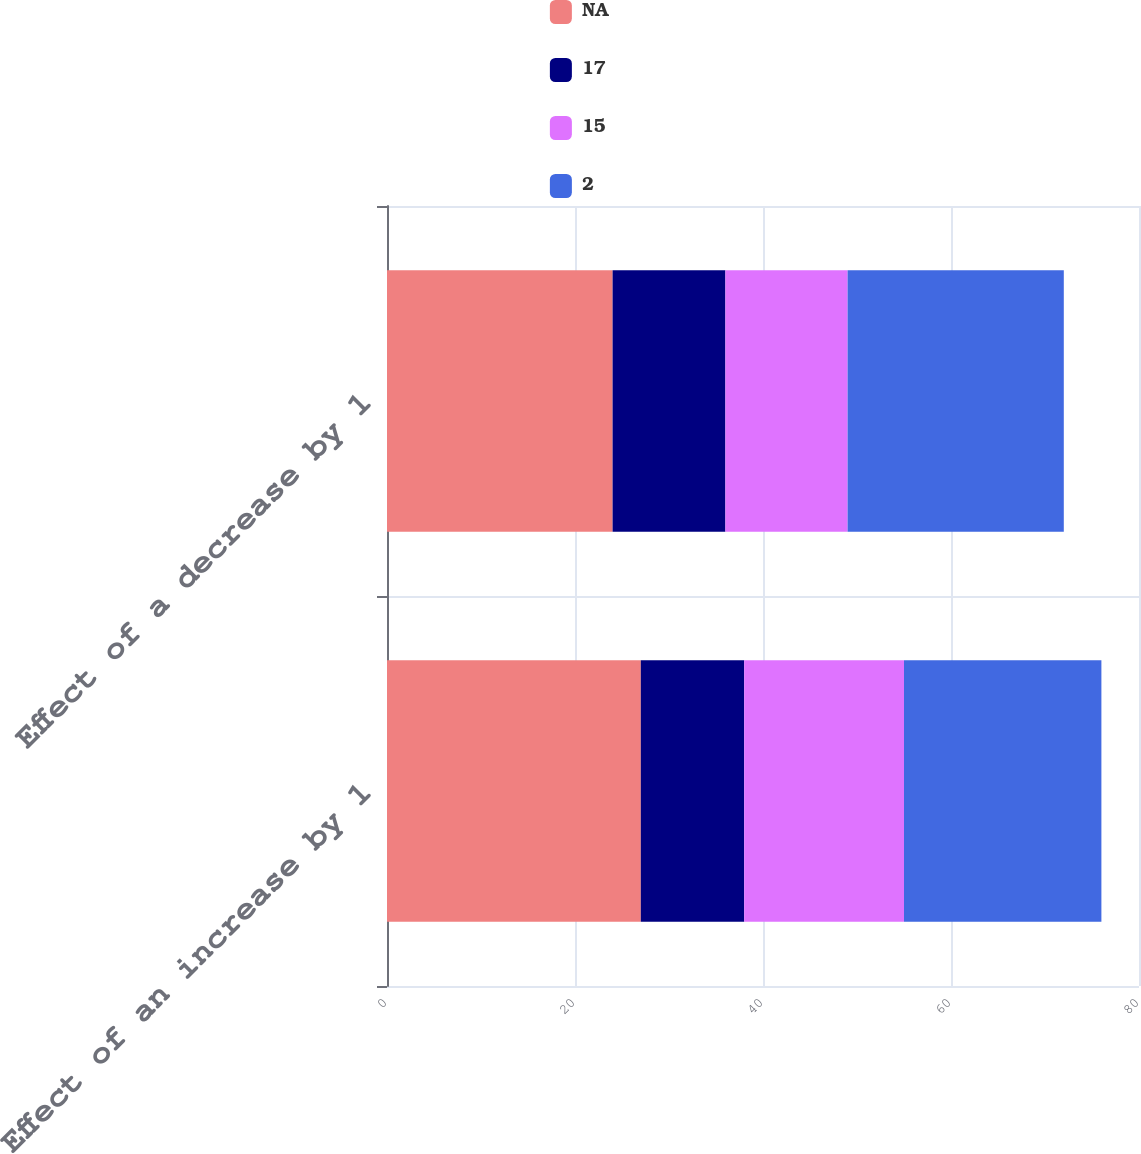<chart> <loc_0><loc_0><loc_500><loc_500><stacked_bar_chart><ecel><fcel>Effect of an increase by 1<fcel>Effect of a decrease by 1<nl><fcel>nan<fcel>27<fcel>24<nl><fcel>17<fcel>11<fcel>12<nl><fcel>15<fcel>17<fcel>13<nl><fcel>2<fcel>21<fcel>23<nl></chart> 